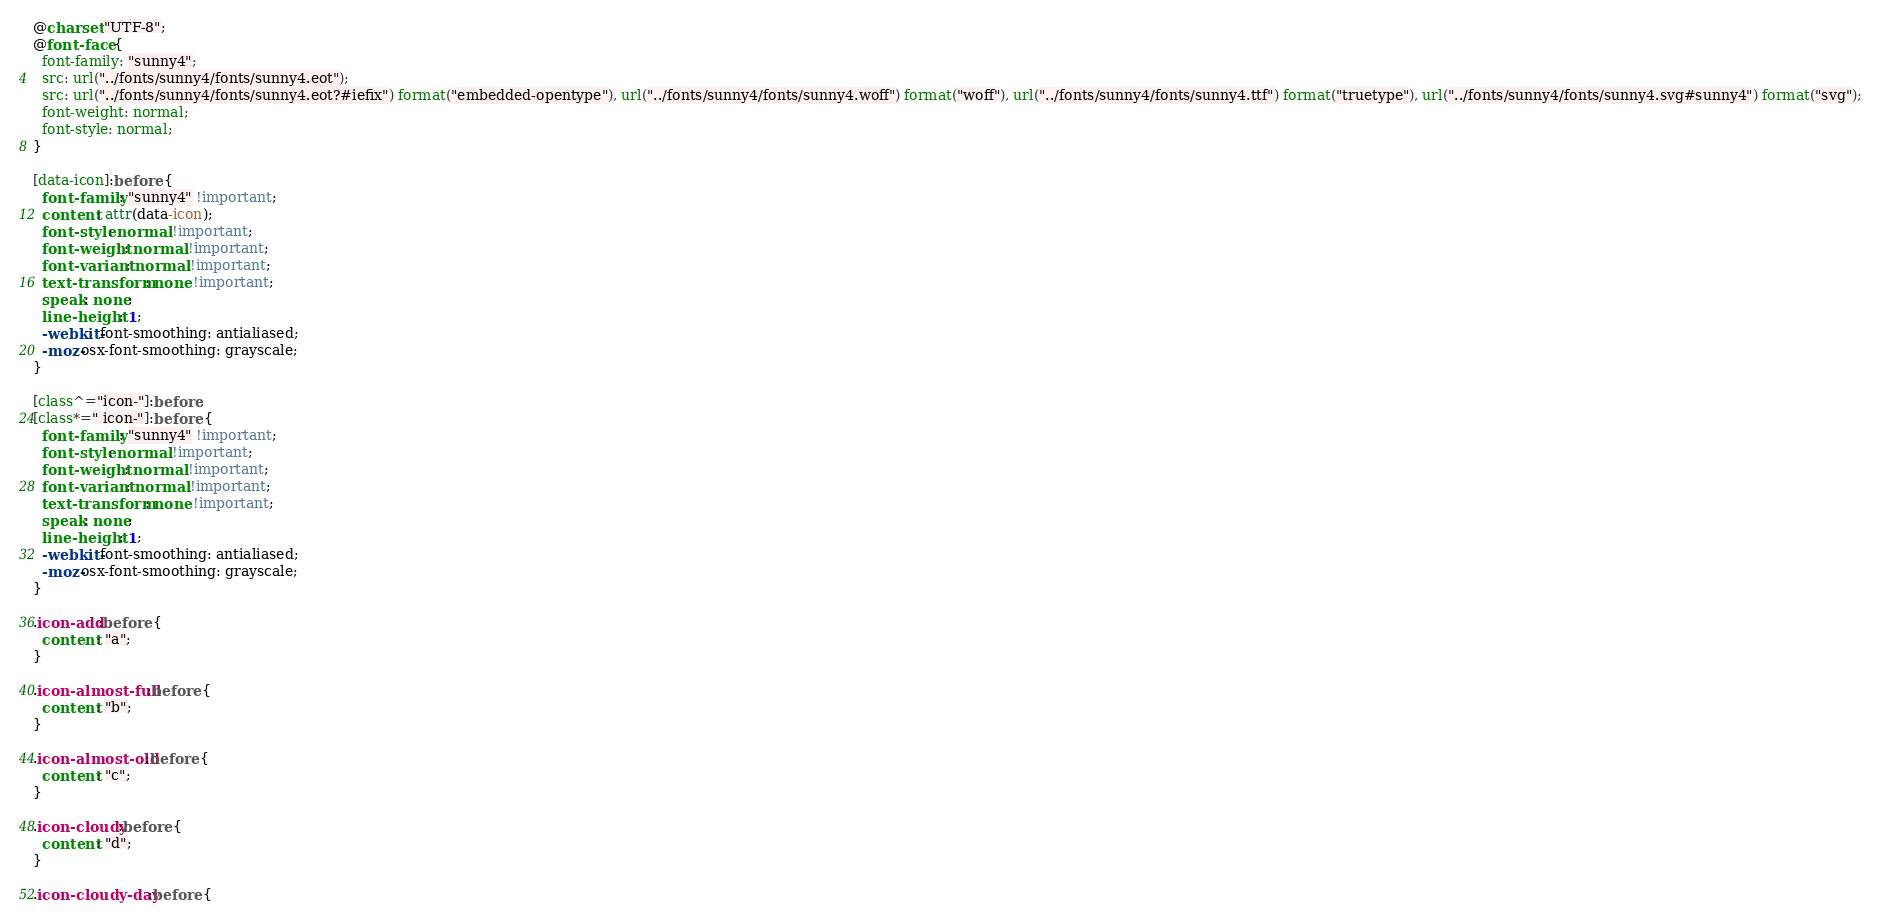<code> <loc_0><loc_0><loc_500><loc_500><_CSS_>@charset "UTF-8";
@font-face {
  font-family: "sunny4";
  src: url("../fonts/sunny4/fonts/sunny4.eot");
  src: url("../fonts/sunny4/fonts/sunny4.eot?#iefix") format("embedded-opentype"), url("../fonts/sunny4/fonts/sunny4.woff") format("woff"), url("../fonts/sunny4/fonts/sunny4.ttf") format("truetype"), url("../fonts/sunny4/fonts/sunny4.svg#sunny4") format("svg");
  font-weight: normal;
  font-style: normal;
}

[data-icon]:before {
  font-family: "sunny4" !important;
  content: attr(data-icon);
  font-style: normal !important;
  font-weight: normal !important;
  font-variant: normal !important;
  text-transform: none !important;
  speak: none;
  line-height: 1;
  -webkit-font-smoothing: antialiased;
  -moz-osx-font-smoothing: grayscale;
}

[class^="icon-"]:before,
[class*=" icon-"]:before {
  font-family: "sunny4" !important;
  font-style: normal !important;
  font-weight: normal !important;
  font-variant: normal !important;
  text-transform: none !important;
  speak: none;
  line-height: 1;
  -webkit-font-smoothing: antialiased;
  -moz-osx-font-smoothing: grayscale;
}

.icon-add:before {
  content: "a";
}

.icon-almost-full:before {
  content: "b";
}

.icon-almost-old:before {
  content: "c";
}

.icon-cloudy:before {
  content: "d";
}

.icon-cloudy-day:before {</code> 